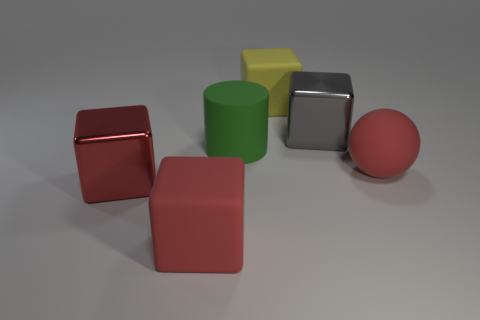Subtract all red rubber cubes. How many cubes are left? 3 Subtract all yellow cubes. How many cubes are left? 3 Add 2 green cylinders. How many objects exist? 8 Subtract all brown cubes. Subtract all green cylinders. How many cubes are left? 4 Subtract all spheres. How many objects are left? 5 Add 5 tiny cyan rubber cubes. How many tiny cyan rubber cubes exist? 5 Subtract 0 gray cylinders. How many objects are left? 6 Subtract all tiny blue blocks. Subtract all large things. How many objects are left? 0 Add 4 rubber spheres. How many rubber spheres are left? 5 